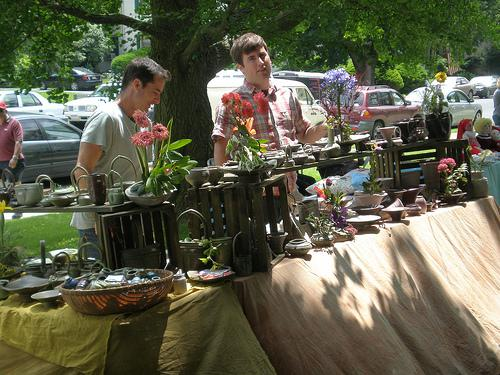Question: when was this?
Choices:
A. At night.
B. Sunset.
C. Daytime.
D. Dawn.
Answer with the letter. Answer: C 